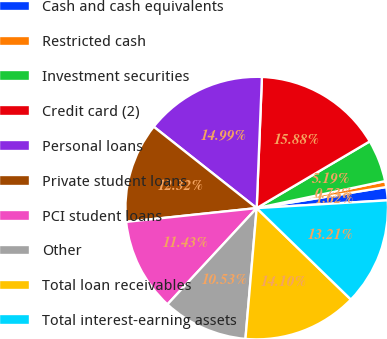Convert chart to OTSL. <chart><loc_0><loc_0><loc_500><loc_500><pie_chart><fcel>Cash and cash equivalents<fcel>Restricted cash<fcel>Investment securities<fcel>Credit card (2)<fcel>Personal loans<fcel>Private student loans<fcel>PCI student loans<fcel>Other<fcel>Total loan receivables<fcel>Total interest-earning assets<nl><fcel>1.62%<fcel>0.73%<fcel>5.19%<fcel>15.88%<fcel>14.99%<fcel>12.32%<fcel>11.43%<fcel>10.53%<fcel>14.1%<fcel>13.21%<nl></chart> 